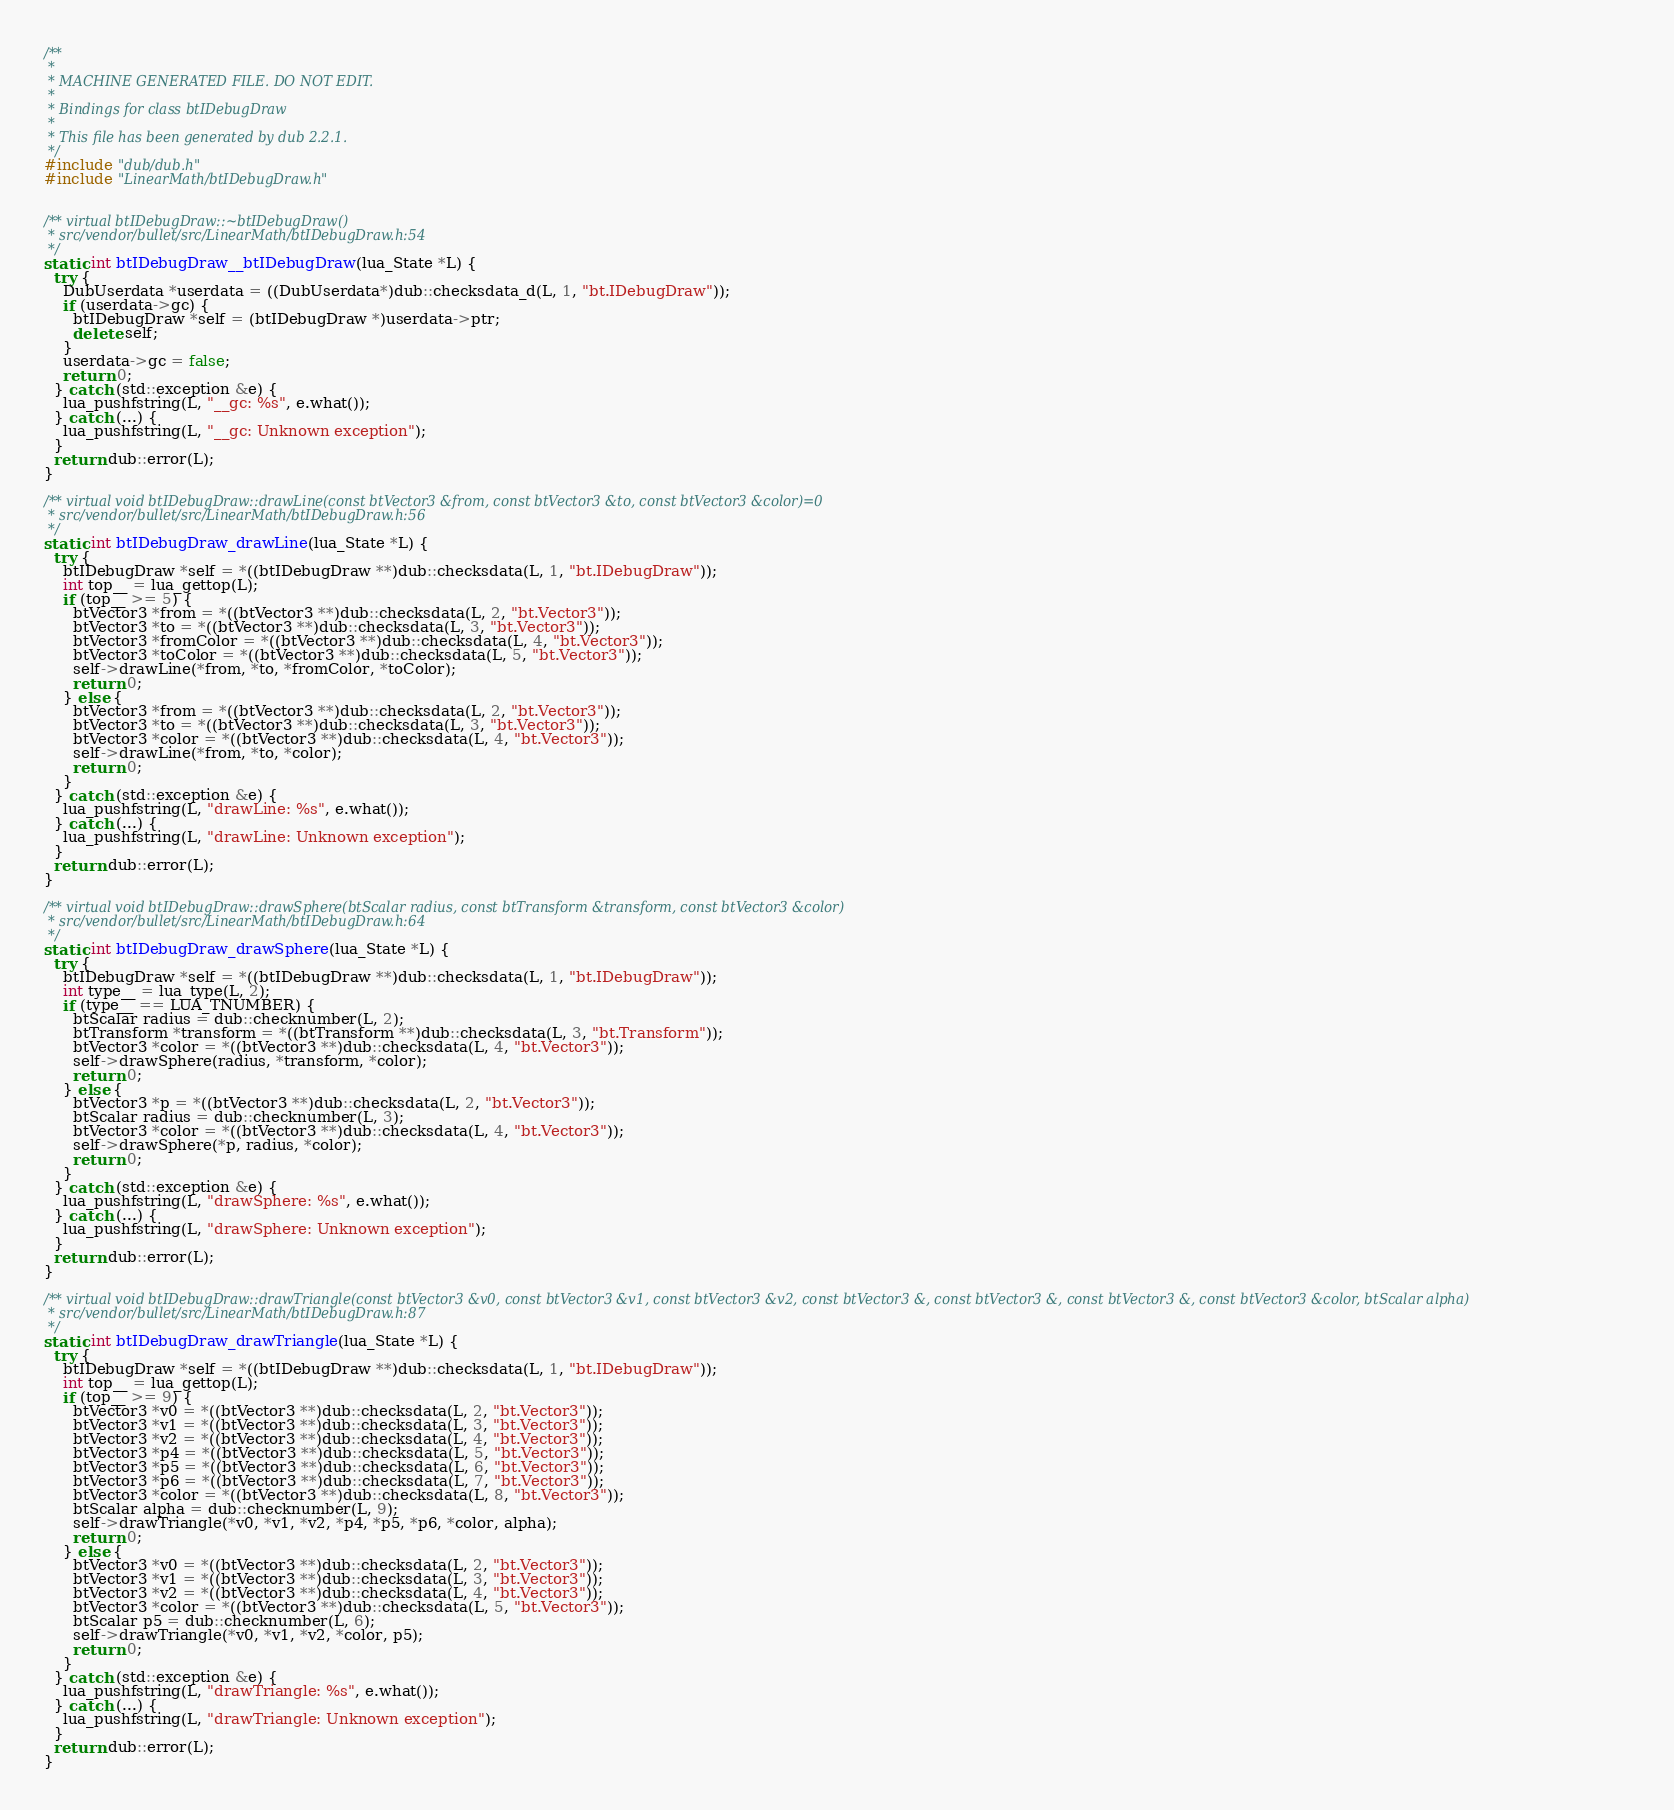<code> <loc_0><loc_0><loc_500><loc_500><_C++_>/**
 *
 * MACHINE GENERATED FILE. DO NOT EDIT.
 *
 * Bindings for class btIDebugDraw
 *
 * This file has been generated by dub 2.2.1.
 */
#include "dub/dub.h"
#include "LinearMath/btIDebugDraw.h"


/** virtual btIDebugDraw::~btIDebugDraw()
 * src/vendor/bullet/src/LinearMath/btIDebugDraw.h:54
 */
static int btIDebugDraw__btIDebugDraw(lua_State *L) {
  try {
    DubUserdata *userdata = ((DubUserdata*)dub::checksdata_d(L, 1, "bt.IDebugDraw"));
    if (userdata->gc) {
      btIDebugDraw *self = (btIDebugDraw *)userdata->ptr;
      delete self;
    }
    userdata->gc = false;
    return 0;
  } catch (std::exception &e) {
    lua_pushfstring(L, "__gc: %s", e.what());
  } catch (...) {
    lua_pushfstring(L, "__gc: Unknown exception");
  }
  return dub::error(L);
}

/** virtual void btIDebugDraw::drawLine(const btVector3 &from, const btVector3 &to, const btVector3 &color)=0
 * src/vendor/bullet/src/LinearMath/btIDebugDraw.h:56
 */
static int btIDebugDraw_drawLine(lua_State *L) {
  try {
    btIDebugDraw *self = *((btIDebugDraw **)dub::checksdata(L, 1, "bt.IDebugDraw"));
    int top__ = lua_gettop(L);
    if (top__ >= 5) {
      btVector3 *from = *((btVector3 **)dub::checksdata(L, 2, "bt.Vector3"));
      btVector3 *to = *((btVector3 **)dub::checksdata(L, 3, "bt.Vector3"));
      btVector3 *fromColor = *((btVector3 **)dub::checksdata(L, 4, "bt.Vector3"));
      btVector3 *toColor = *((btVector3 **)dub::checksdata(L, 5, "bt.Vector3"));
      self->drawLine(*from, *to, *fromColor, *toColor);
      return 0;
    } else {
      btVector3 *from = *((btVector3 **)dub::checksdata(L, 2, "bt.Vector3"));
      btVector3 *to = *((btVector3 **)dub::checksdata(L, 3, "bt.Vector3"));
      btVector3 *color = *((btVector3 **)dub::checksdata(L, 4, "bt.Vector3"));
      self->drawLine(*from, *to, *color);
      return 0;
    }
  } catch (std::exception &e) {
    lua_pushfstring(L, "drawLine: %s", e.what());
  } catch (...) {
    lua_pushfstring(L, "drawLine: Unknown exception");
  }
  return dub::error(L);
}

/** virtual void btIDebugDraw::drawSphere(btScalar radius, const btTransform &transform, const btVector3 &color)
 * src/vendor/bullet/src/LinearMath/btIDebugDraw.h:64
 */
static int btIDebugDraw_drawSphere(lua_State *L) {
  try {
    btIDebugDraw *self = *((btIDebugDraw **)dub::checksdata(L, 1, "bt.IDebugDraw"));
    int type__ = lua_type(L, 2);
    if (type__ == LUA_TNUMBER) {
      btScalar radius = dub::checknumber(L, 2);
      btTransform *transform = *((btTransform **)dub::checksdata(L, 3, "bt.Transform"));
      btVector3 *color = *((btVector3 **)dub::checksdata(L, 4, "bt.Vector3"));
      self->drawSphere(radius, *transform, *color);
      return 0;
    } else {
      btVector3 *p = *((btVector3 **)dub::checksdata(L, 2, "bt.Vector3"));
      btScalar radius = dub::checknumber(L, 3);
      btVector3 *color = *((btVector3 **)dub::checksdata(L, 4, "bt.Vector3"));
      self->drawSphere(*p, radius, *color);
      return 0;
    }
  } catch (std::exception &e) {
    lua_pushfstring(L, "drawSphere: %s", e.what());
  } catch (...) {
    lua_pushfstring(L, "drawSphere: Unknown exception");
  }
  return dub::error(L);
}

/** virtual void btIDebugDraw::drawTriangle(const btVector3 &v0, const btVector3 &v1, const btVector3 &v2, const btVector3 &, const btVector3 &, const btVector3 &, const btVector3 &color, btScalar alpha)
 * src/vendor/bullet/src/LinearMath/btIDebugDraw.h:87
 */
static int btIDebugDraw_drawTriangle(lua_State *L) {
  try {
    btIDebugDraw *self = *((btIDebugDraw **)dub::checksdata(L, 1, "bt.IDebugDraw"));
    int top__ = lua_gettop(L);
    if (top__ >= 9) {
      btVector3 *v0 = *((btVector3 **)dub::checksdata(L, 2, "bt.Vector3"));
      btVector3 *v1 = *((btVector3 **)dub::checksdata(L, 3, "bt.Vector3"));
      btVector3 *v2 = *((btVector3 **)dub::checksdata(L, 4, "bt.Vector3"));
      btVector3 *p4 = *((btVector3 **)dub::checksdata(L, 5, "bt.Vector3"));
      btVector3 *p5 = *((btVector3 **)dub::checksdata(L, 6, "bt.Vector3"));
      btVector3 *p6 = *((btVector3 **)dub::checksdata(L, 7, "bt.Vector3"));
      btVector3 *color = *((btVector3 **)dub::checksdata(L, 8, "bt.Vector3"));
      btScalar alpha = dub::checknumber(L, 9);
      self->drawTriangle(*v0, *v1, *v2, *p4, *p5, *p6, *color, alpha);
      return 0;
    } else {
      btVector3 *v0 = *((btVector3 **)dub::checksdata(L, 2, "bt.Vector3"));
      btVector3 *v1 = *((btVector3 **)dub::checksdata(L, 3, "bt.Vector3"));
      btVector3 *v2 = *((btVector3 **)dub::checksdata(L, 4, "bt.Vector3"));
      btVector3 *color = *((btVector3 **)dub::checksdata(L, 5, "bt.Vector3"));
      btScalar p5 = dub::checknumber(L, 6);
      self->drawTriangle(*v0, *v1, *v2, *color, p5);
      return 0;
    }
  } catch (std::exception &e) {
    lua_pushfstring(L, "drawTriangle: %s", e.what());
  } catch (...) {
    lua_pushfstring(L, "drawTriangle: Unknown exception");
  }
  return dub::error(L);
}
</code> 